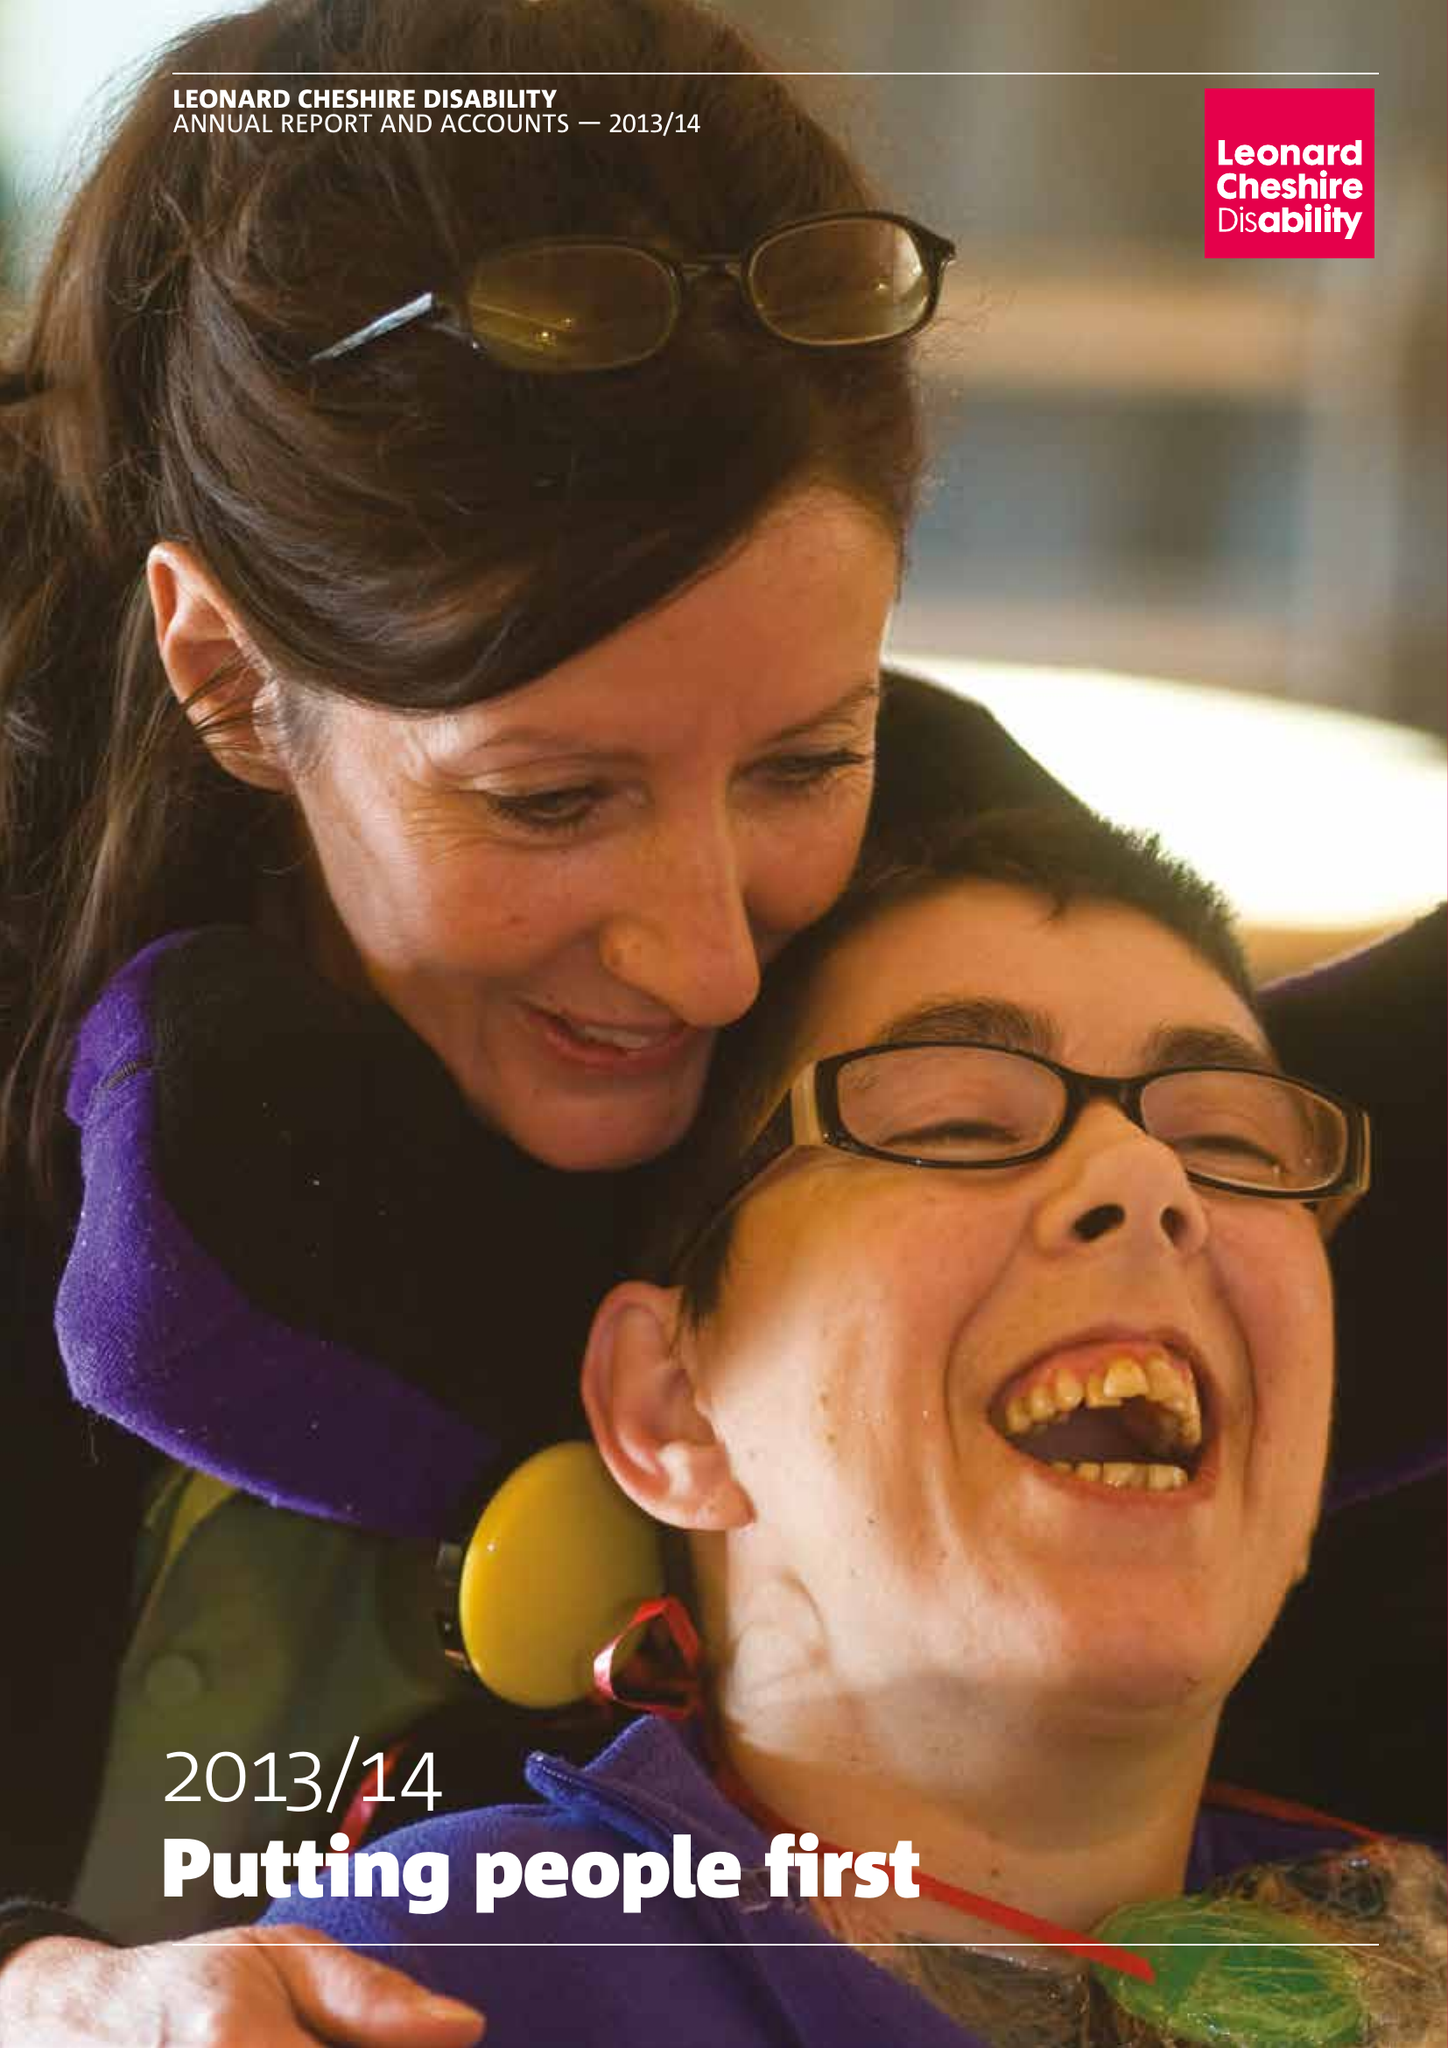What is the value for the charity_name?
Answer the question using a single word or phrase. Leonard Cheshire Disability 